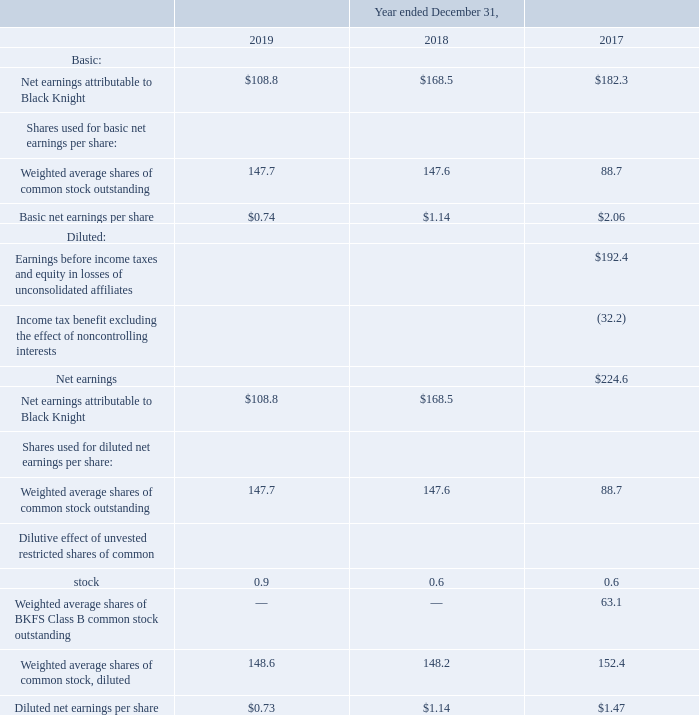(5) Earnings Per Share
Basic earnings per share is computed by dividing Net earnings attributable to Black Knight by the weighted-average number of shares of common stock outstanding during the period.
For the periods presented, potentially dilutive securities include unvested restricted stock awards and the shares of BKFS Class B common stock prior to the Distribution. For the year ended December 31, 2017, the numerator in the diluted net earnings per share calculation is adjusted to reflect our income tax expense at an expected effective tax rate assuming the conversion of the shares of BKFS Class B common stock into shares of BKFS Class A common stock on a one-for-one basis prior to the Distribution. The effective tax rate for the year ended December 31, 2017 was (16.7)%, including the effect of the benefit related to the revaluation of our net deferred income tax liability and certain other discrete items recorded during 2017. For the year ended December 31, 2017, the denominator includes approximately 63.1 million shares of BKFS Class B common stock outstanding prior to the Distribution. The denominator also includes the dilutive effect of approximately 0.9 million, 0.6 million and 0.6 million shares of unvested restricted shares of common stock for the years ended December 31, 2019, 2018 and 2017, respectively.
The shares of BKFS Class B common stock did not share in the earnings or losses of Black Knight and were, therefore, not participating securities. Accordingly, basic and diluted net earnings per share of BKFS Class B common stock have not been presented.
The computation of basic and diluted earnings per share is as follows (in millions, except per share amounts):
How did the company compute basic earnings per share? Dividing net earnings attributable to black knight by the weighted-average number of shares of common stock outstanding during the period. What years does the table provide information for the computation of basic and diluted earnings per share is as follows (in millions, except per share? 2019, 2018, 2017. What were the basic Net earnings attributable to Black Knight in 2017?
Answer scale should be: million. 182.3. What was the change in the basic net earnings attributable to Black Knight between 2017 and 2018?
Answer scale should be: million. 168.5-182.3
Answer: -13.8. What was the change in the basic net earnings per share between 2017 and 2019? 0.74-2.06
Answer: -1.32. What was the percentage change in Diluted net earnings per share between 2018 and 2019?
Answer scale should be: percent. (0.73-1.14)/1.14
Answer: -35.96. 